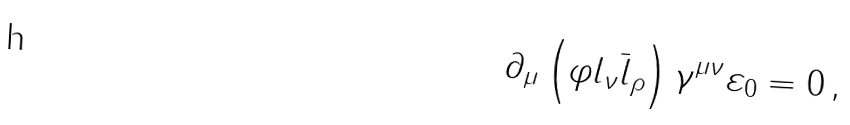Convert formula to latex. <formula><loc_0><loc_0><loc_500><loc_500>\partial _ { \mu } \left ( \varphi l _ { \nu } \bar { l } _ { \rho } \right ) \gamma ^ { \mu \nu } \varepsilon _ { 0 } = 0 \, ,</formula> 